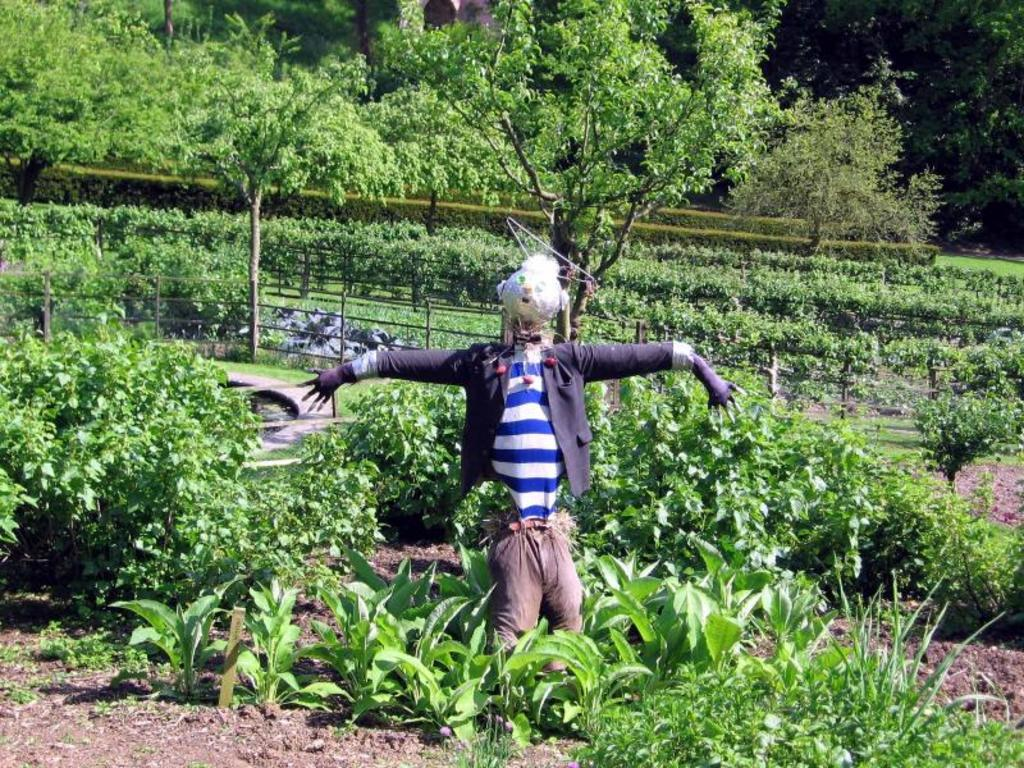What is the main subject of the image? There is a depiction of a person in the image. What is surrounding the person in the image? There are plants around the person. What is located behind the person in the image? There is a metal fence behind the person. What can be seen in the background of the image? There are trees in the background of the image. How many beds can be seen in the image? There are no beds present in the image. What type of horn is being played by the person in the image? There is no horn present in the image, and the person is not playing any instrument. 